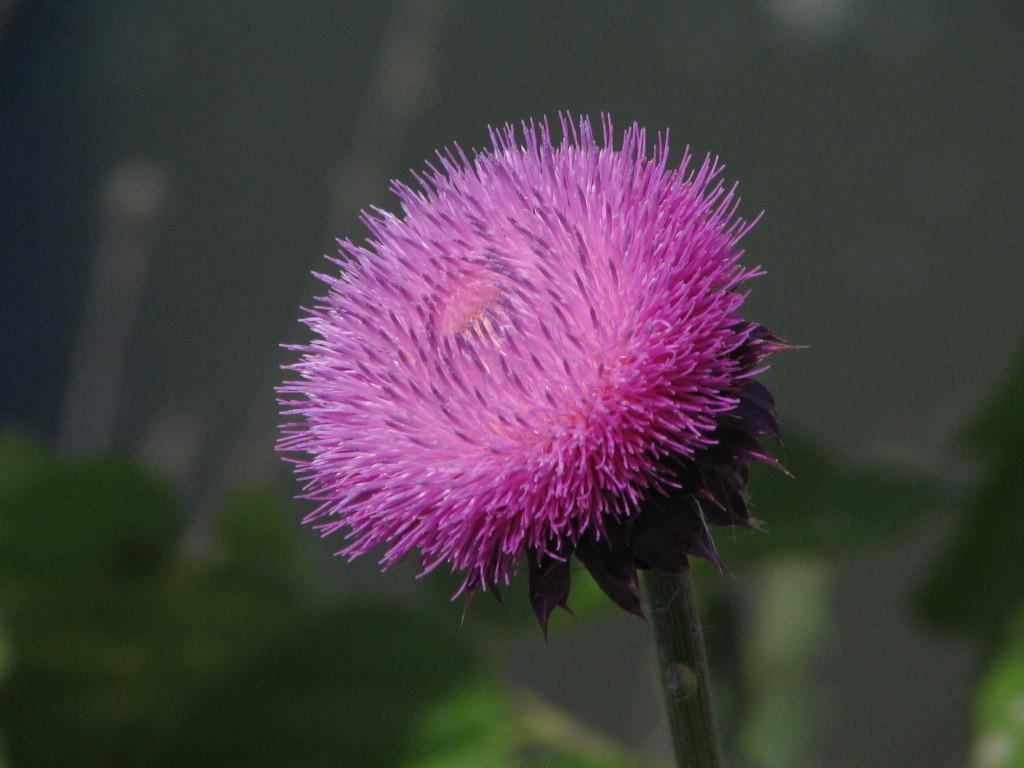What is the main subject of the image? There is a flower in the image, and it is the main focus. Can you describe the flower in the image? Unfortunately, the facts provided do not give any details about the flower's appearance. However, we can confirm that it is the main focus of the image. What type of pan is being used by the servant in the image? There is no pan or servant present in the image. The image only features a flower as the main focus. 